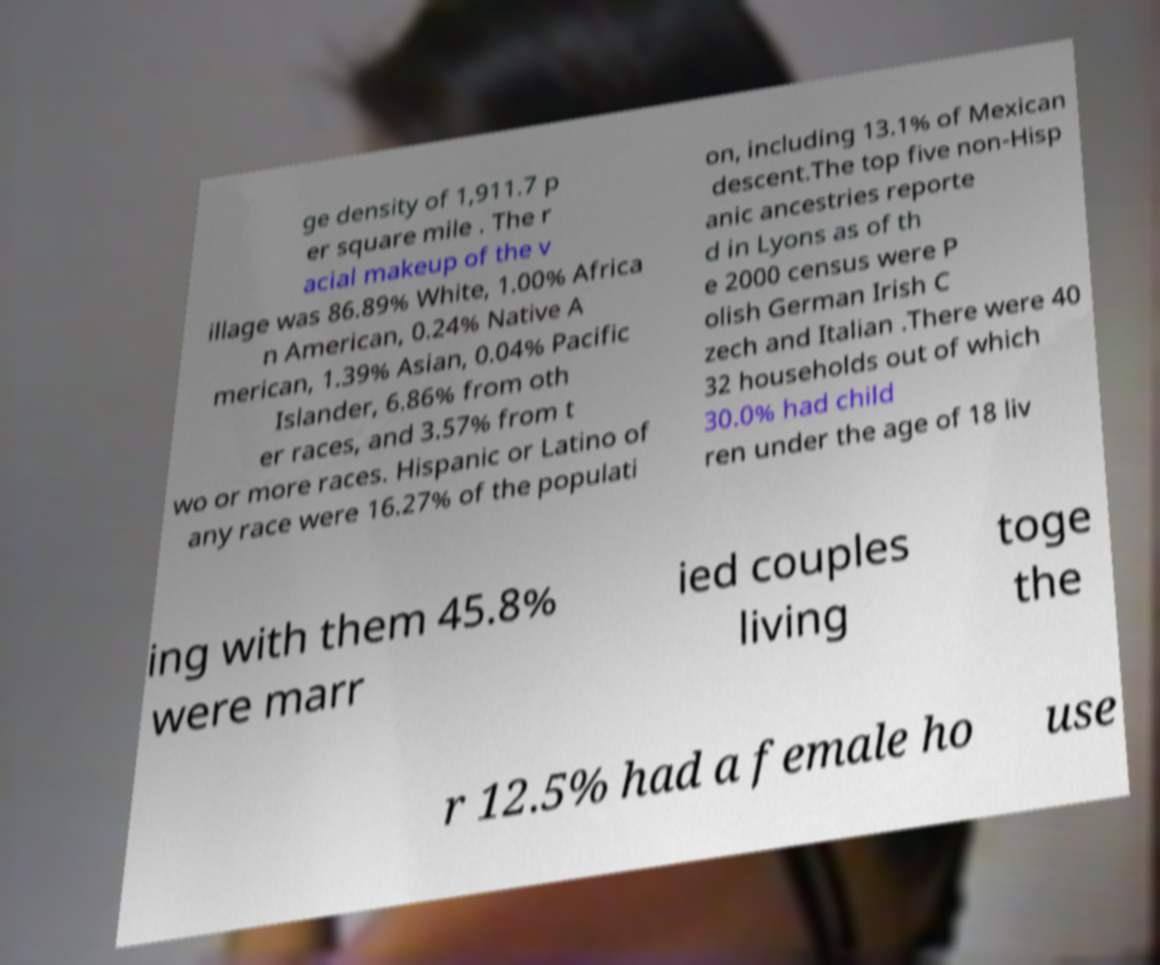Can you read and provide the text displayed in the image?This photo seems to have some interesting text. Can you extract and type it out for me? ge density of 1,911.7 p er square mile . The r acial makeup of the v illage was 86.89% White, 1.00% Africa n American, 0.24% Native A merican, 1.39% Asian, 0.04% Pacific Islander, 6.86% from oth er races, and 3.57% from t wo or more races. Hispanic or Latino of any race were 16.27% of the populati on, including 13.1% of Mexican descent.The top five non-Hisp anic ancestries reporte d in Lyons as of th e 2000 census were P olish German Irish C zech and Italian .There were 40 32 households out of which 30.0% had child ren under the age of 18 liv ing with them 45.8% were marr ied couples living toge the r 12.5% had a female ho use 